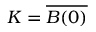<formula> <loc_0><loc_0><loc_500><loc_500>K = { \overline { B ( 0 ) } }</formula> 